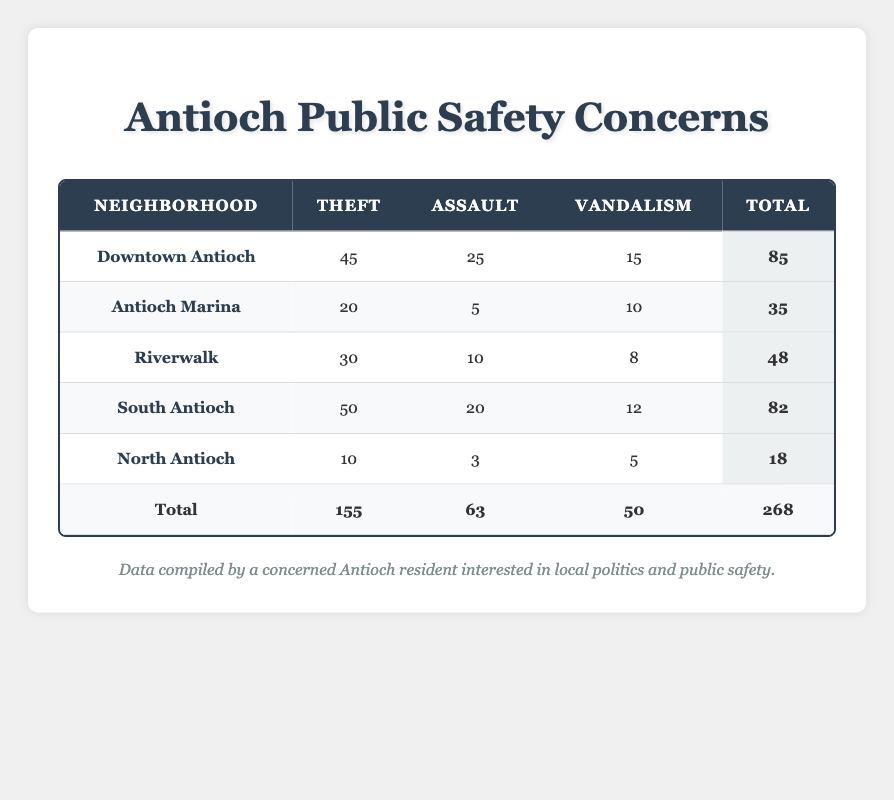What neighborhood has the highest number of reported thefts? Referring to the table, the "Theft" column shows "South Antioch" with the highest case count of 50 thefts.
Answer: South Antioch What is the total count of assaults in Downtown Antioch? Looking at the table under "Downtown Antioch," the "Assault" column shows a case count of 25.
Answer: 25 Which neighborhood experienced the least amount of vandalism? By examining the "Vandalism" column, "North Antioch" has the lowest case count of 5, compared to other neighborhoods.
Answer: North Antioch Is the total number of thefts greater than the total number of assaults in the table? The total number of thefts is 155 and assaults is 63. Since 155 is greater than 63, the answer is yes.
Answer: Yes What is the total count of public safety concerns reported for South Antioch and Riverwalk combined? For South Antioch, the total is 82 and for Riverwalk, it is 48. Adding them together gives 82 + 48 = 130.
Answer: 130 Which neighborhood has the highest combined total of theft, assault, and vandalism? Calculating the totals: Downtown Antioch = 85, Antioch Marina = 35, Riverwalk = 48, South Antioch = 82, North Antioch = 18. The highest total is 85 in Downtown Antioch.
Answer: Downtown Antioch Does any neighborhood have a higher number of assaults than vandalism? Comparing the "Assault" and "Vandalism" columns for each neighborhood, "Downtown Antioch" has 25 assaults and 15 vandalism, which is the only neighborhood with higher assaults.
Answer: Yes What is the average number of thefts across all neighborhoods? The total thefts are 155 and there are 5 neighborhoods, so the average is 155 / 5 = 31.
Answer: 31 What percentage of total public safety concerns are made up of thefts? The total public safety concerns are 268, and thefts count is 155. The percentage is (155 / 268) * 100 ≈ 57.79%.
Answer: Approximately 57.79% 